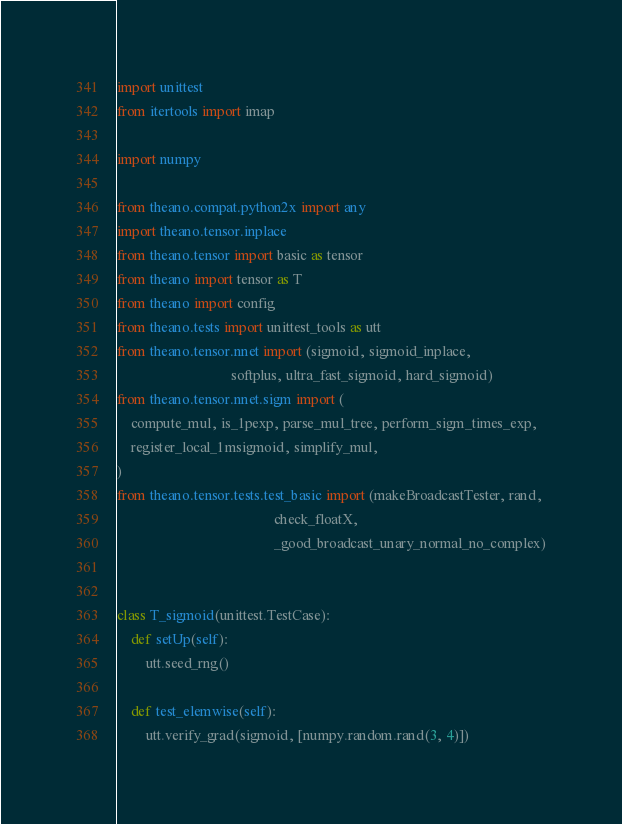Convert code to text. <code><loc_0><loc_0><loc_500><loc_500><_Python_>import unittest
from itertools import imap

import numpy

from theano.compat.python2x import any
import theano.tensor.inplace
from theano.tensor import basic as tensor
from theano import tensor as T
from theano import config
from theano.tests import unittest_tools as utt
from theano.tensor.nnet import (sigmoid, sigmoid_inplace,
                                softplus, ultra_fast_sigmoid, hard_sigmoid)
from theano.tensor.nnet.sigm import (
    compute_mul, is_1pexp, parse_mul_tree, perform_sigm_times_exp,
    register_local_1msigmoid, simplify_mul,
)
from theano.tensor.tests.test_basic import (makeBroadcastTester, rand,
                                            check_floatX,
                                            _good_broadcast_unary_normal_no_complex)


class T_sigmoid(unittest.TestCase):
    def setUp(self):
        utt.seed_rng()

    def test_elemwise(self):
        utt.verify_grad(sigmoid, [numpy.random.rand(3, 4)])

</code> 